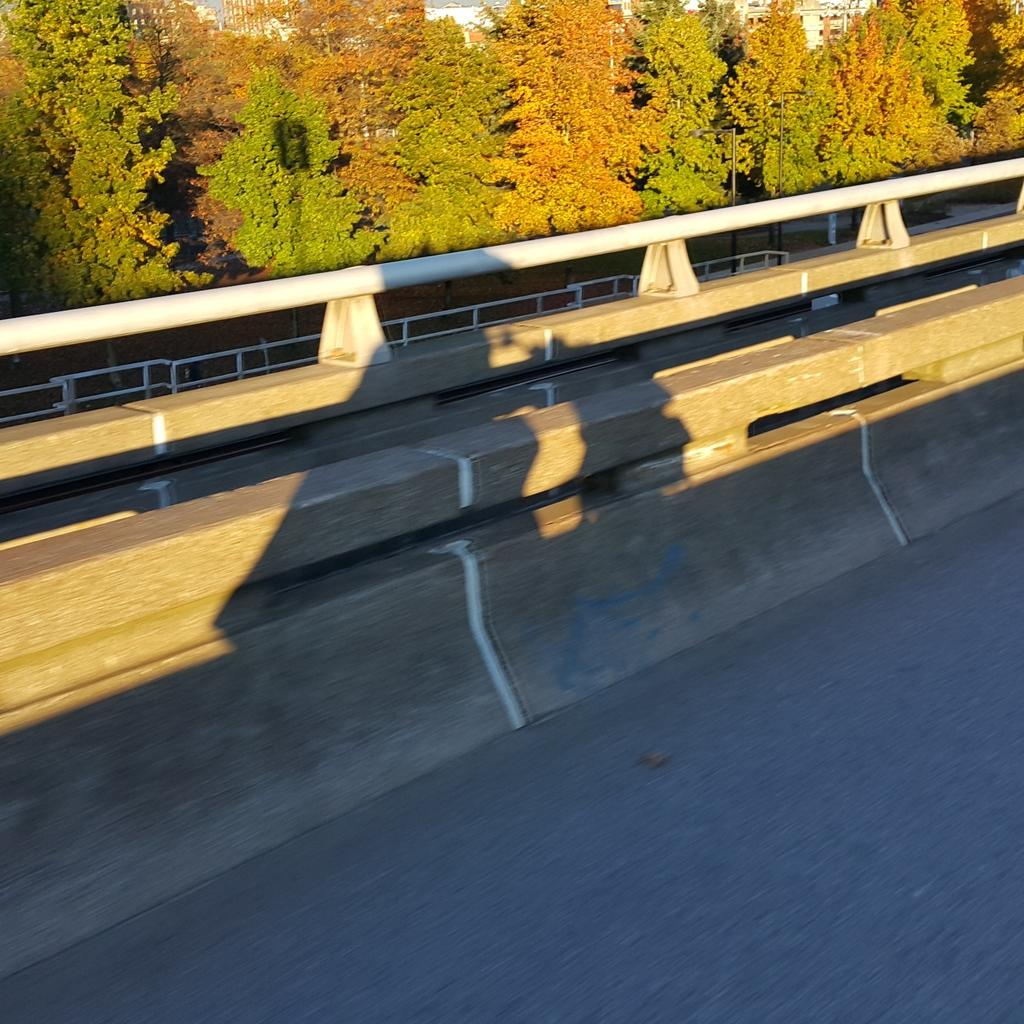What is located in the foreground of the image? There is a fence, a road, trees, and buildings in the foreground of the image. What type of structures can be seen in the foreground? The structures in the foreground are buildings. What can be inferred about the time of day the image was taken? The image is likely taken during the day, as there is sufficient light to see the details clearly. What type of scarf is being used to support the tree in the image? There is no scarf present in the image, and the trees are not being supported by any scarf. How many parcels can be seen on the road in the image? There are no parcels visible in the image; only a fence, a road, trees, and buildings are present. 